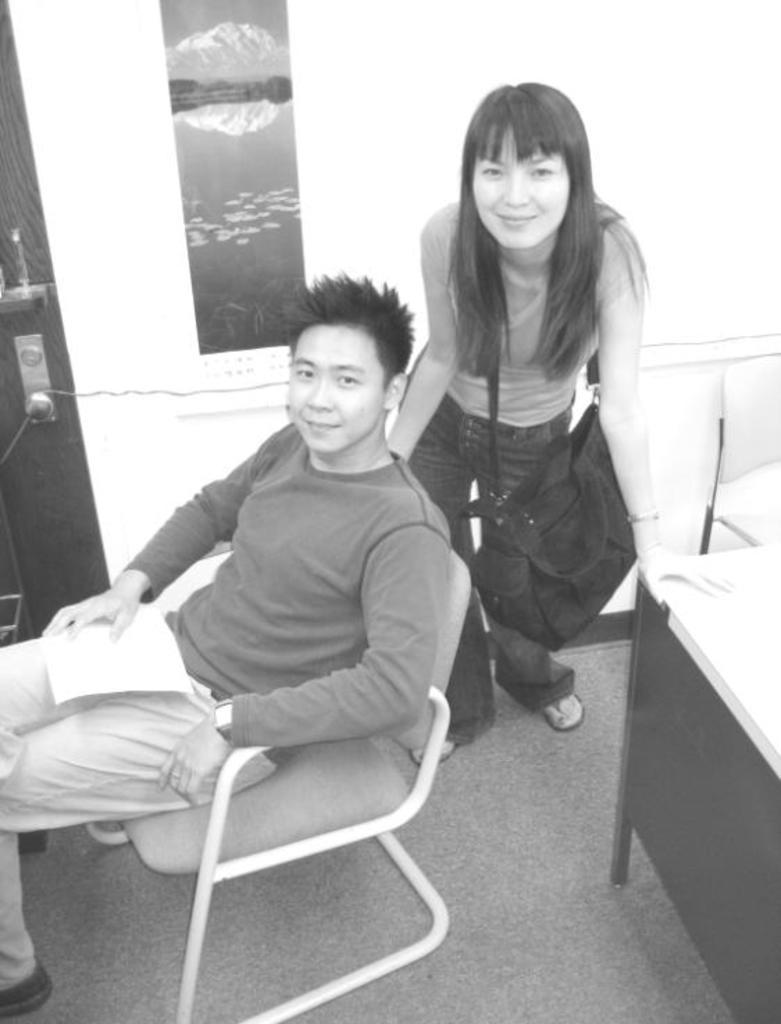What is the man in the image doing? The man is sitting on a chair in the image. Where is the man looking in the image? The man is looking at somewhere in the image. Can you describe the woman in the image? There is a woman on the right side of the image. What type of dolls can be seen on the man's desk in the image? There are no dolls present in the image. 